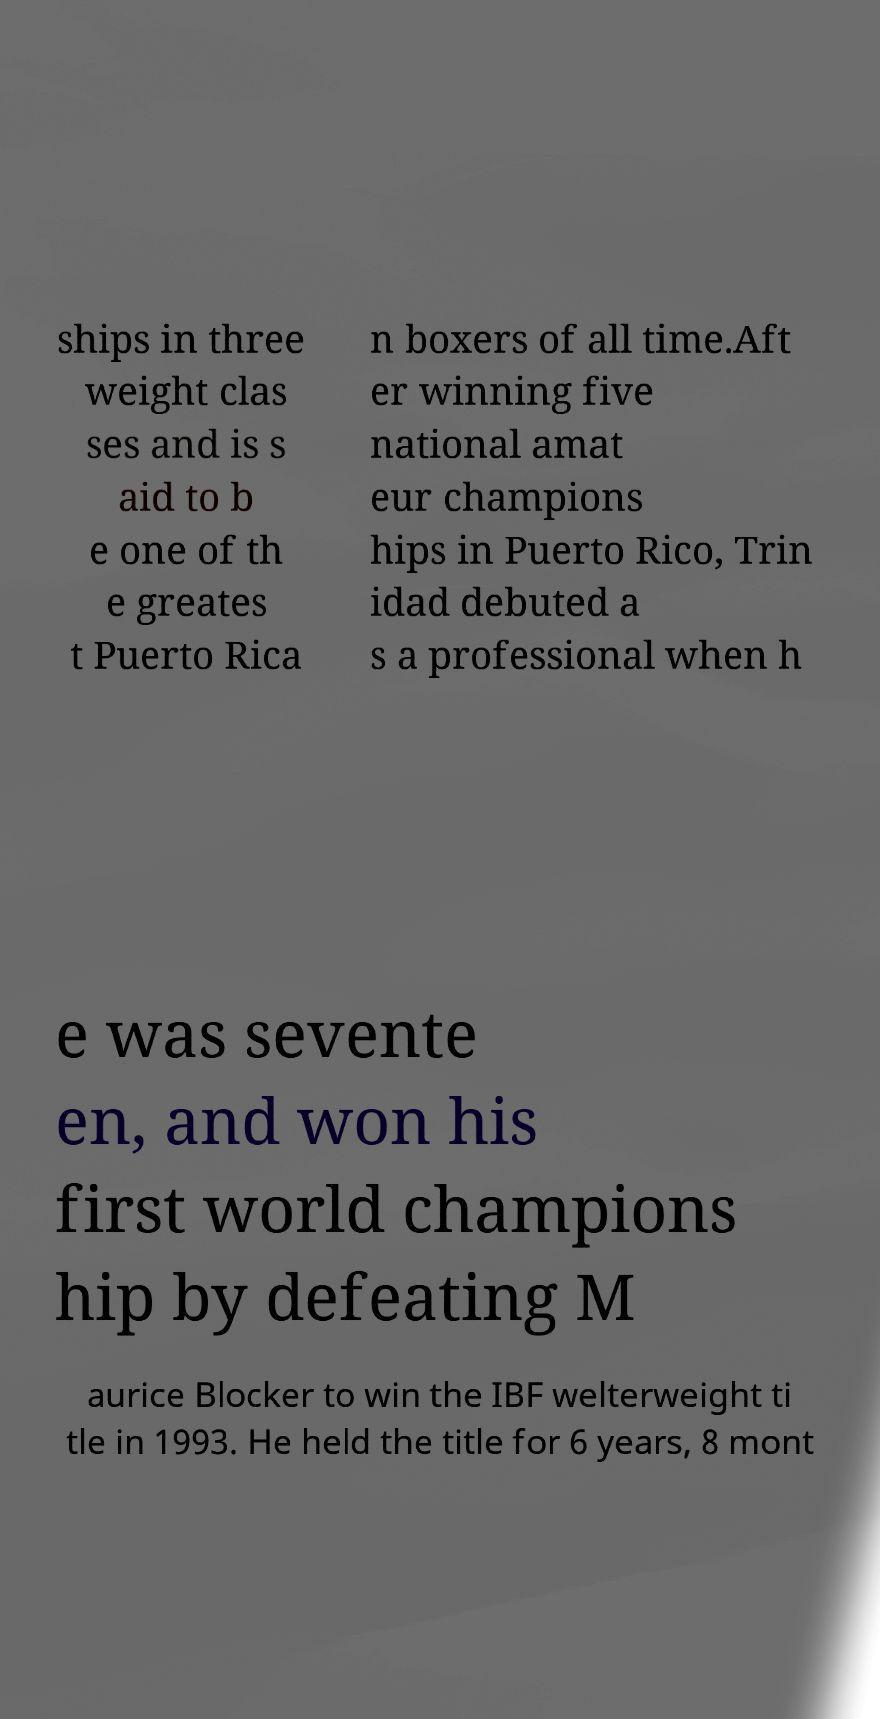Could you extract and type out the text from this image? ships in three weight clas ses and is s aid to b e one of th e greates t Puerto Rica n boxers of all time.Aft er winning five national amat eur champions hips in Puerto Rico, Trin idad debuted a s a professional when h e was sevente en, and won his first world champions hip by defeating M aurice Blocker to win the IBF welterweight ti tle in 1993. He held the title for 6 years, 8 mont 